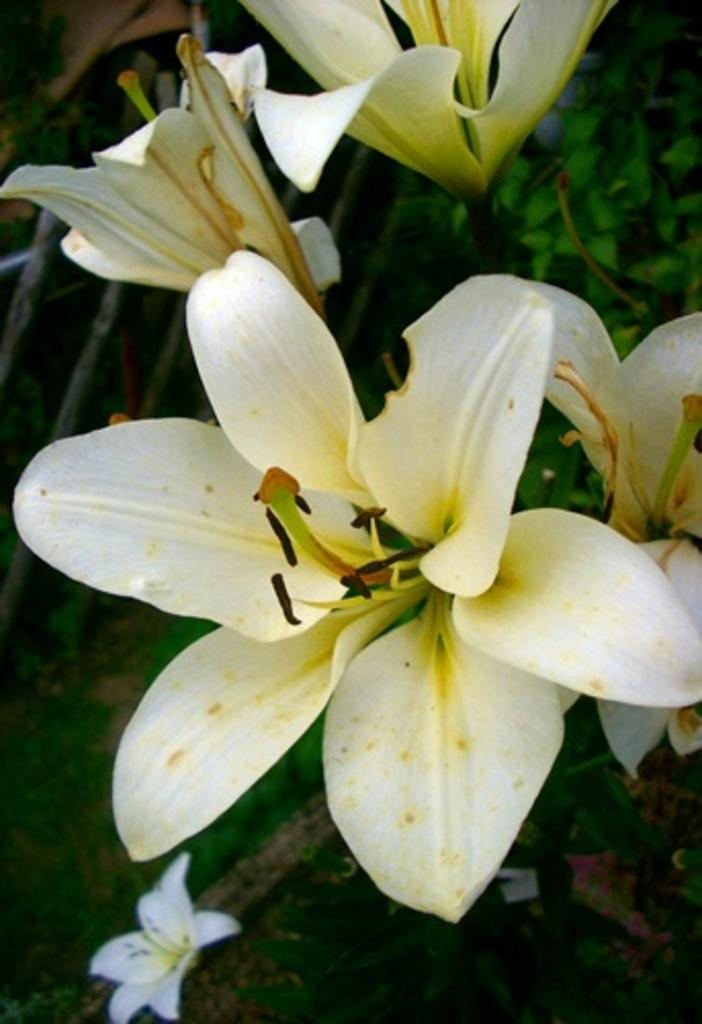What type of plants can be seen in the image? There are flowers in the image. What is the color of the flowers? The flowers are white in color. What other parts of the plants are visible in the image? There are leaves visible at the top of the image. What type of pan is used to cook the flowers in the image? There is no pan or cooking involved in the image; it simply shows white flowers with leaves. 